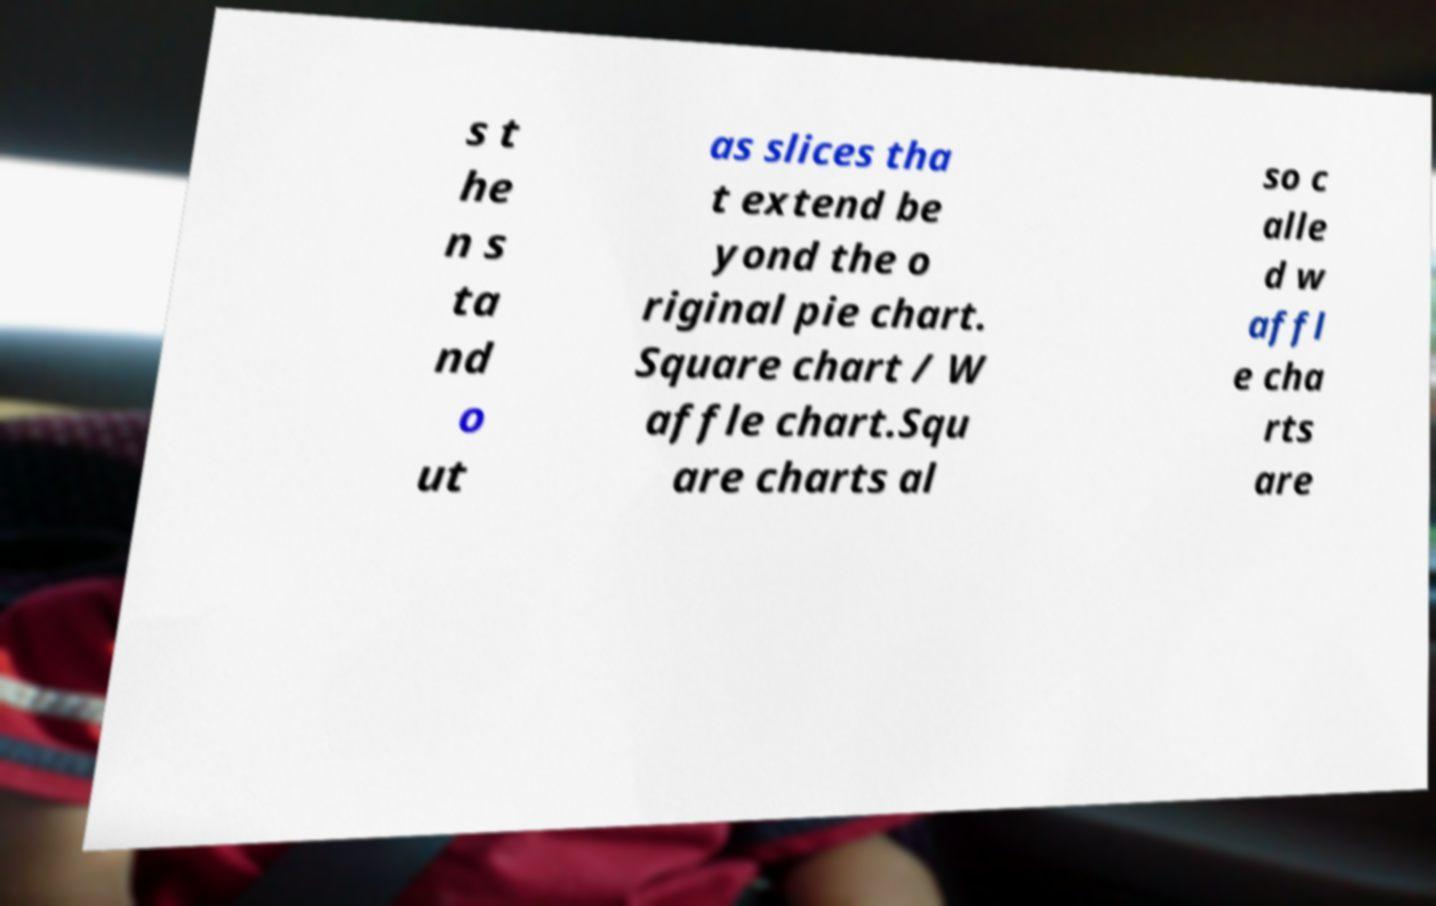Can you accurately transcribe the text from the provided image for me? s t he n s ta nd o ut as slices tha t extend be yond the o riginal pie chart. Square chart / W affle chart.Squ are charts al so c alle d w affl e cha rts are 